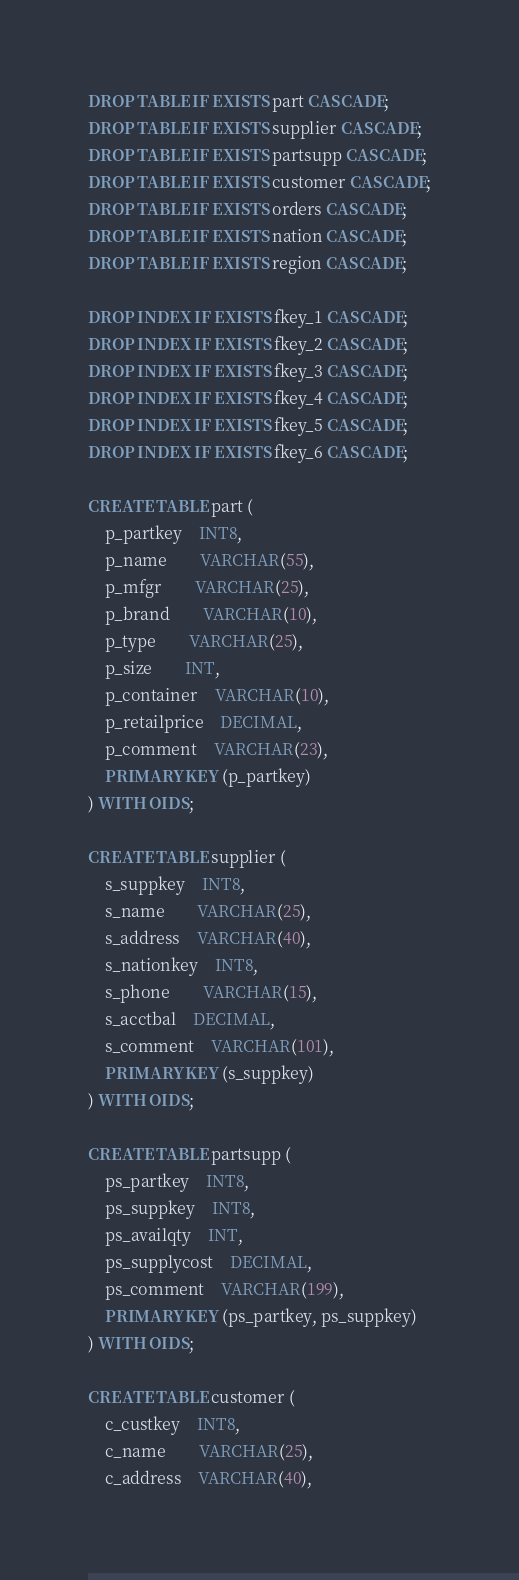<code> <loc_0><loc_0><loc_500><loc_500><_SQL_>DROP TABLE IF EXISTS part CASCADE;
DROP TABLE IF EXISTS supplier CASCADE;
DROP TABLE IF EXISTS partsupp CASCADE;
DROP TABLE IF EXISTS customer CASCADE;
DROP TABLE IF EXISTS orders CASCADE;
DROP TABLE IF EXISTS nation CASCADE;
DROP TABLE IF EXISTS region CASCADE;

DROP INDEX IF EXISTS fkey_1 CASCADE;
DROP INDEX IF EXISTS fkey_2 CASCADE;
DROP INDEX IF EXISTS fkey_3 CASCADE;
DROP INDEX IF EXISTS fkey_4 CASCADE;
DROP INDEX IF EXISTS fkey_5 CASCADE;
DROP INDEX IF EXISTS fkey_6 CASCADE;

CREATE TABLE part (
	p_partkey 	INT8,
	p_name		VARCHAR(55),
	p_mfgr		VARCHAR(25),
	p_brand		VARCHAR(10),
	p_type		VARCHAR(25),
	p_size		INT,
	p_container	VARCHAR(10),
	p_retailprice	DECIMAL,
	p_comment	VARCHAR(23),
	PRIMARY KEY (p_partkey)
) WITH OIDS;

CREATE TABLE supplier (
	s_suppkey	INT8,
	s_name		VARCHAR(25),
	s_address	VARCHAR(40),
	s_nationkey	INT8,
	s_phone		VARCHAR(15),
	s_acctbal	DECIMAL,
	s_comment	VARCHAR(101),
	PRIMARY KEY (s_suppkey)
) WITH OIDS;

CREATE TABLE partsupp (
	ps_partkey	INT8,
	ps_suppkey	INT8,
	ps_availqty	INT,
	ps_supplycost	DECIMAL,
	ps_comment	VARCHAR(199),
	PRIMARY KEY (ps_partkey, ps_suppkey)
) WITH OIDS;

CREATE TABLE customer (
	c_custkey	INT8,
	c_name		VARCHAR(25),
	c_address	VARCHAR(40),</code> 